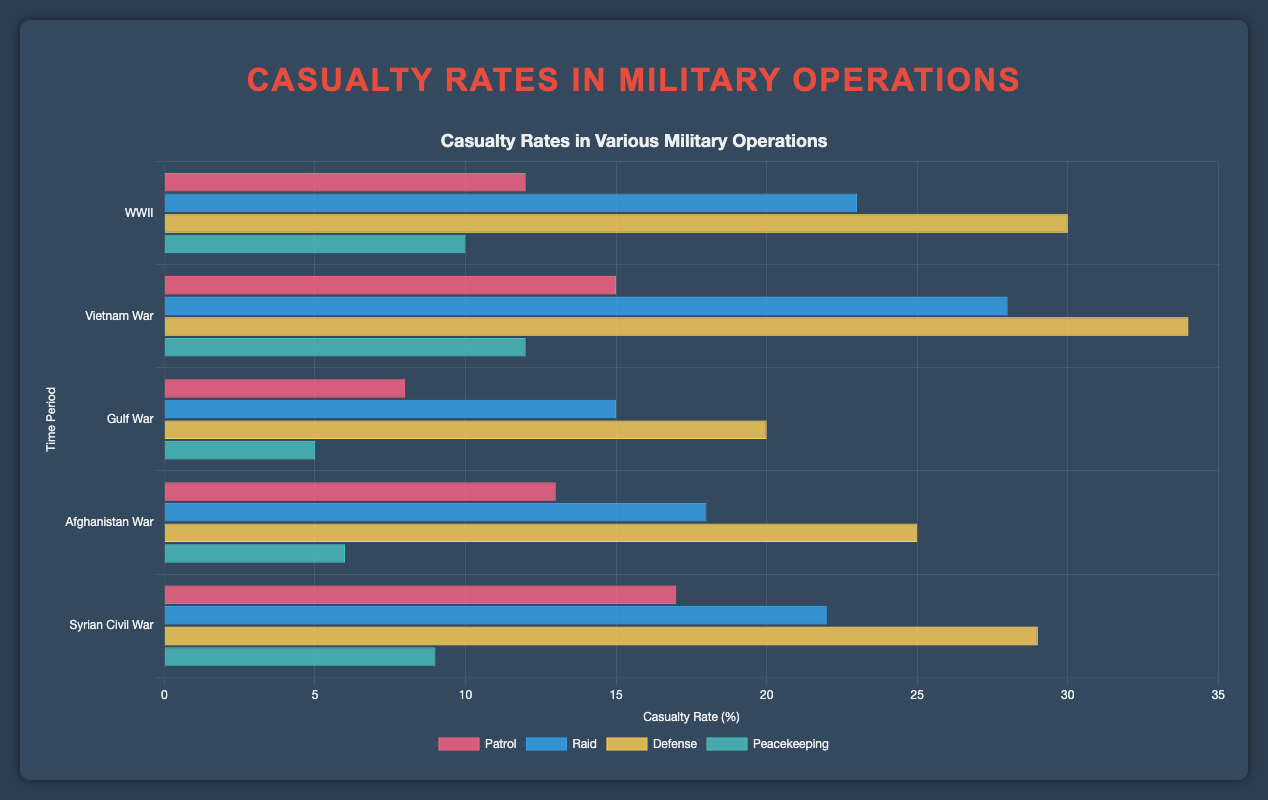Which military operation type had the highest casualty rate during WWII? Look at the bars grouped under WWII. Compare their heights. The bar representing "Defense" is the tallest, indicating the highest casualty rate.
Answer: Defense During which time period did peacekeeping operations have the lowest casualty rate? Examine the bars for "Peacekeeping" across all time periods. The "Gulf War" period has the shortest bar, indicating the lowest casualty rate.
Answer: Gulf War What was the total casualty rate for all operation types during the Vietnam War? Sum the casualty rates for all operation types under the Vietnam War period: 15 (Patrol) + 28 (Raid) + 34 (Defense) + 12 (Peacekeeping) = 89
Answer: 89 How does the casualty rate of patrol operations in the Syrian Civil War compare to that in the Afghanistan War? Locate the bars for "Patrol" in the Syrian Civil War and Afghanistan War periods. The Syrian Civil War bar is taller with a rate of 17, compared to the Afghanistan War's rate of 13.
Answer: Syrian Civil War: 17, Afghanistan War: 13 In which time period was the difference between the casualty rates of Raid and Defense operations the smallest, and what was that difference? Calculate the difference between "Raid" and "Defense" rates for each period: 
- WWII: (30 - 23) = 7
- Vietnam War: (34 - 28) = 6
- Gulf War: (20 - 15) = 5
- Afghanistan War: (25 - 18) = 7
- Syrian Civil War: (29 - 22) = 7
The smallest difference is 5 during the Gulf War.
Answer: Gulf War, 5 What is the average casualty rate for Defense operations across all periods? Calculate the sum of the defense casualty rates and divide by the number of periods: (30+34+20+25+29)/5 = 27.6
Answer: 27.6 Which operation type generally had the lowest casualty rates across all periods? Look at the overall trend for each operation type. The "Peacekeeping" operations generally have the shortest bars across all time periods.
Answer: Peacekeeping What is the sum of the casualty rates for Patrolling and Peacekeeping operations during the Gulf War? Add the casualty rates for "Patrol" and "Peacekeeping" in the Gulf War period: 8 (Patrol) + 5 (Peacekeeping) = 13
Answer: 13 Compare the casualty rate of Defense operations in WWII and the Afghanistan War. Which period had a higher rate and by how much? Compare the heights of the "Defense" bars for WWII (30) and Afghanistan War (25). WWII had a higher rate by 30 - 25 = 5.
Answer: WWII by 5 What is the difference in the casualty rates for Raids between the Vietnam War and the Syrian Civil War? Subtract the "Raid" casualty rate in the Syrian Civil War (22) from that in the Vietnam War (28): 28 - 22 = 6
Answer: 6 